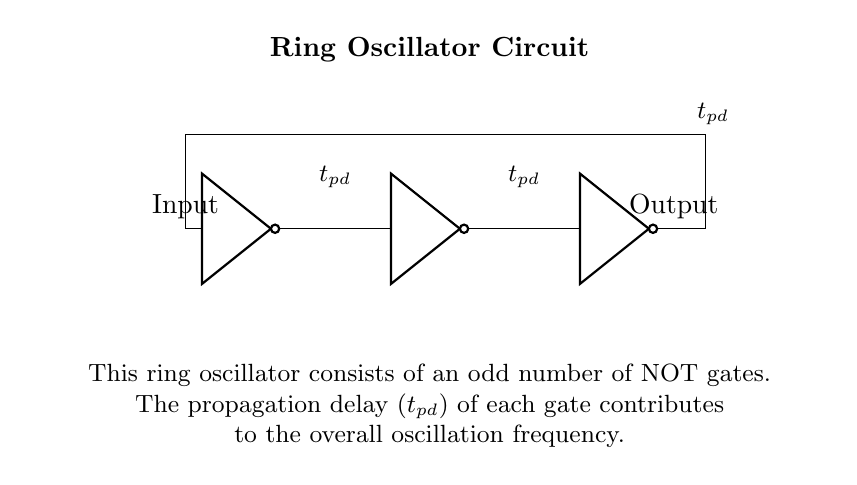What type of gates are used in this circuit? This circuit uses NOT gates, as indicated by the symbols in the diagram. Each gate is labeled clearly in the diagram, confirming that all components are NOT gates.
Answer: NOT gates How many NOT gates are there in the ring oscillator? The circuit shows three NOT gates in a sequential arrangement, which is crucial for the operation of the ring oscillator, as it requires an odd number of gates to function properly.
Answer: Three What is the role of propagation delay in this circuit? Propagation delay is the time it takes for the input signal to affect the output signal. In a ring oscillator, each gate's propagation delay influences the overall oscillation period, and the total delay determines the frequency of oscillation.
Answer: Determines frequency How does the output relate to the input in a ring oscillator? The output of a ring oscillator is a periodic signal that continually changes state based on the input signal. In a ring configuration with odd gates, the output will oscillate between high and low states after passing through the series of NOT gates.
Answer: Oscillates between states What happens if one NOT gate fails in this circuit? If one NOT gate fails, the circuit would lose its ability to oscillate, potentially stopping the output from changing states. Each gate contributes to the feedback loop necessary for maintaining oscillation, so a failure disrupts the cycle.
Answer: Stops oscillation How does the number of gates affect the oscillation frequency? Increasing the number of NOT gates in the ring oscillator increases the total propagation delay, which inversely affects the oscillation frequency. With more gates, the time it takes for a complete cycle of oscillation becomes longer, reducing the frequency.
Answer: Decreases frequency 